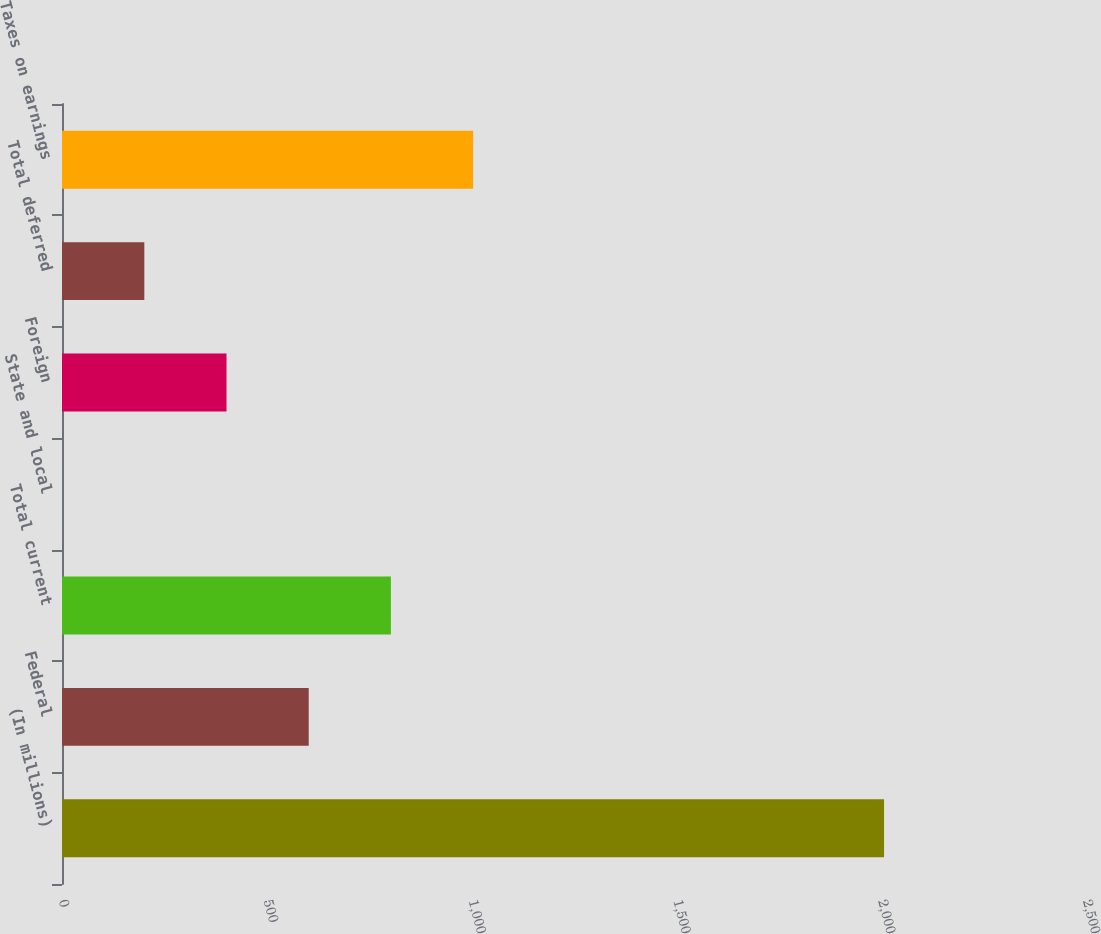Convert chart. <chart><loc_0><loc_0><loc_500><loc_500><bar_chart><fcel>(In millions)<fcel>Federal<fcel>Total current<fcel>State and local<fcel>Foreign<fcel>Total deferred<fcel>Taxes on earnings<nl><fcel>2007<fcel>602.31<fcel>802.98<fcel>0.3<fcel>401.64<fcel>200.97<fcel>1003.65<nl></chart> 